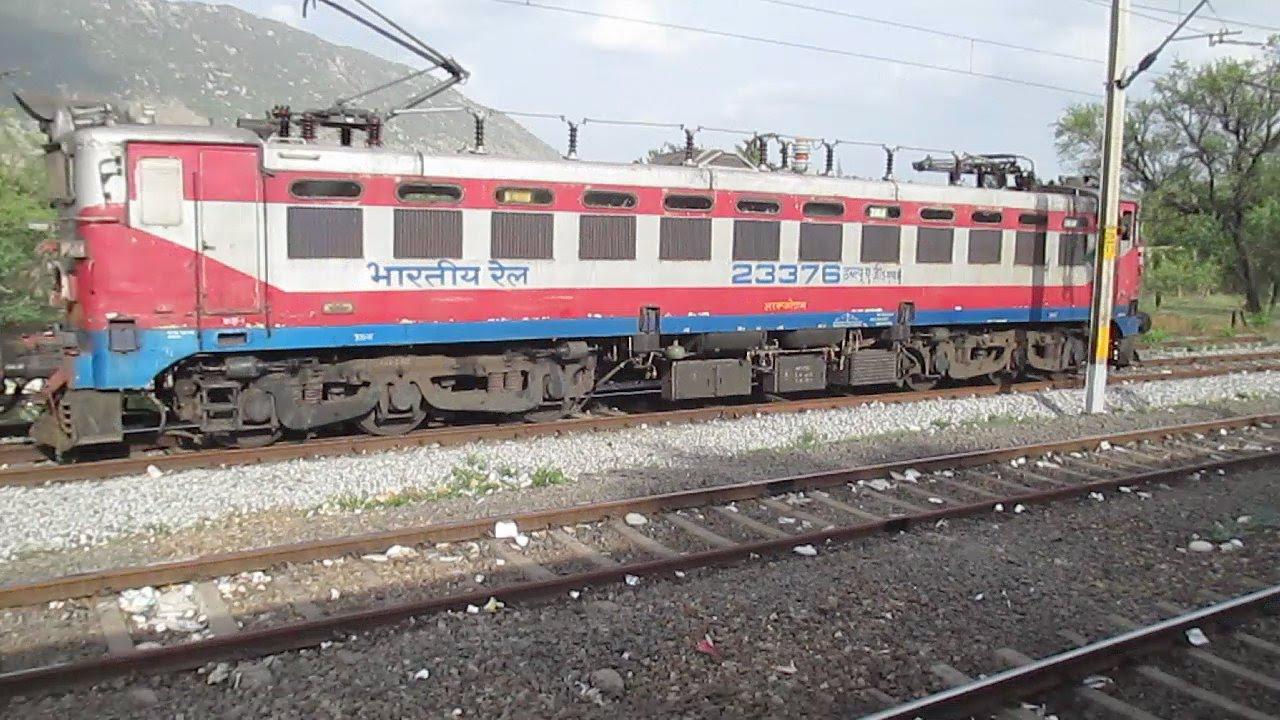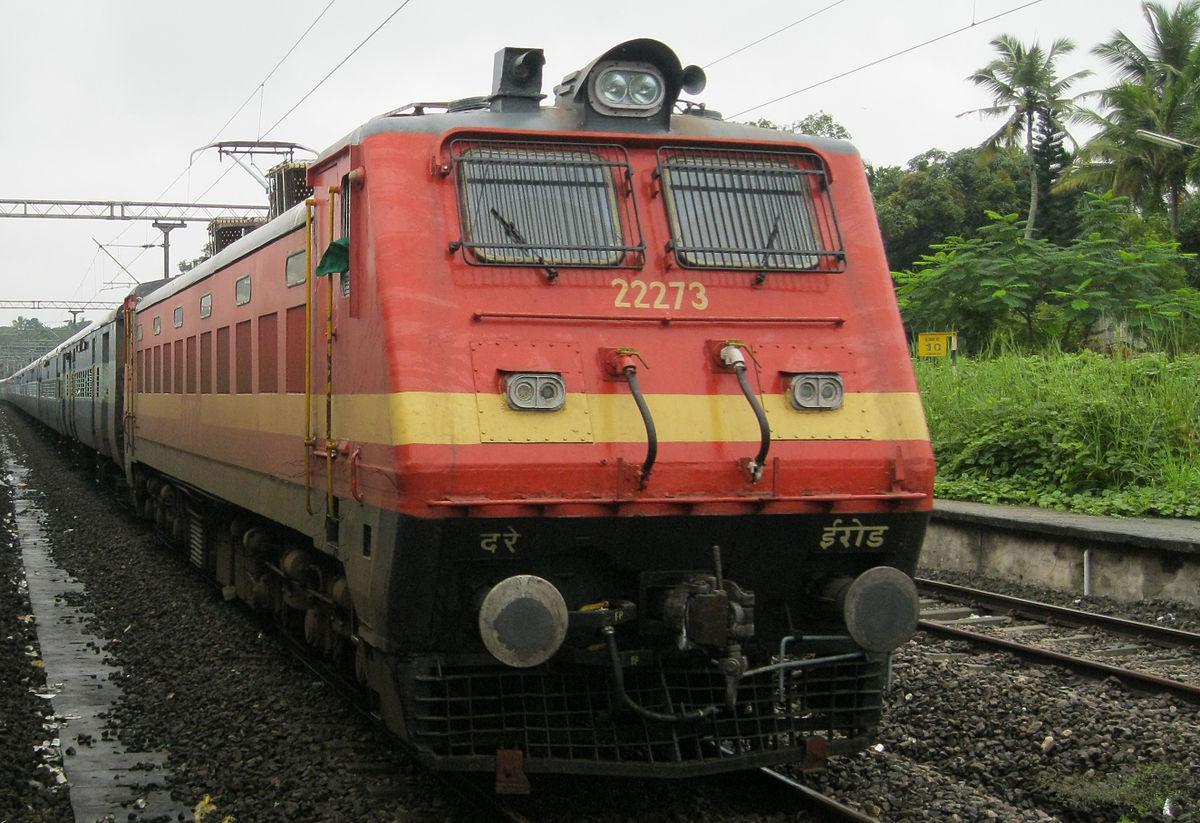The first image is the image on the left, the second image is the image on the right. Analyze the images presented: Is the assertion "The train in the image on the left is moving towards the left." valid? Answer yes or no. Yes. The first image is the image on the left, the second image is the image on the right. For the images displayed, is the sentence "The images include exactly one train with a yellow-striped green front car, and it is headed rightward." factually correct? Answer yes or no. No. 